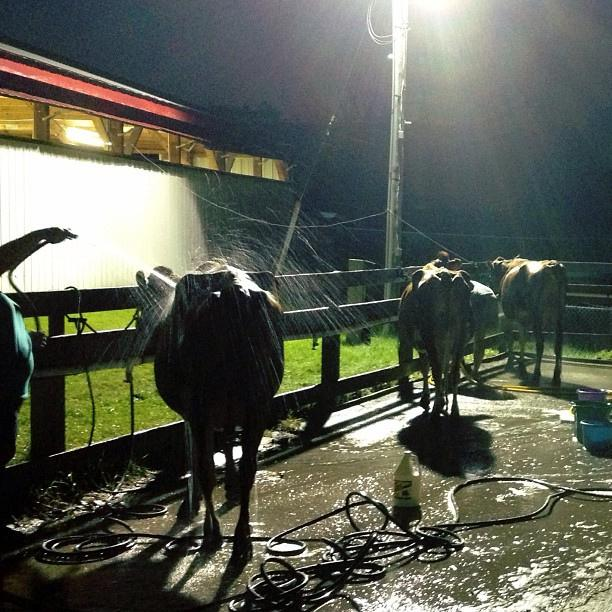What is happening in the photo?

Choices:
A) thunderstorm
B) flooding
C) cow showering
D) raining cow showering 